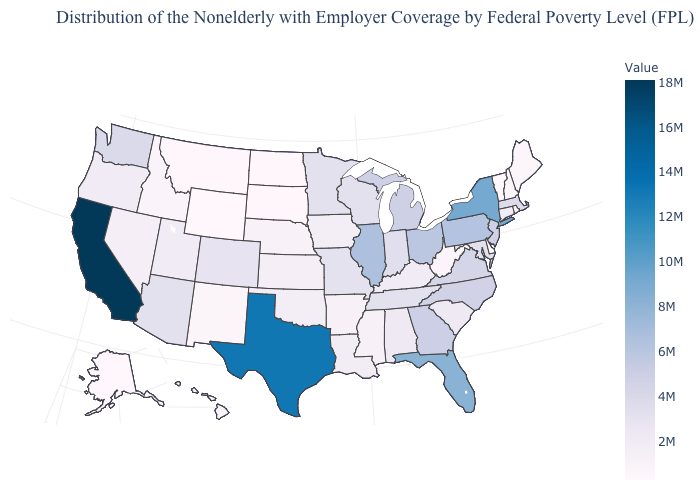Among the states that border West Virginia , which have the lowest value?
Write a very short answer. Kentucky. Among the states that border Nevada , which have the highest value?
Be succinct. California. Does Idaho have the lowest value in the West?
Give a very brief answer. No. Which states have the highest value in the USA?
Keep it brief. California. Does Tennessee have the highest value in the South?
Concise answer only. No. Does Montana have a higher value than New Jersey?
Give a very brief answer. No. Does Ohio have the lowest value in the MidWest?
Be succinct. No. Among the states that border Alabama , which have the lowest value?
Quick response, please. Mississippi. 